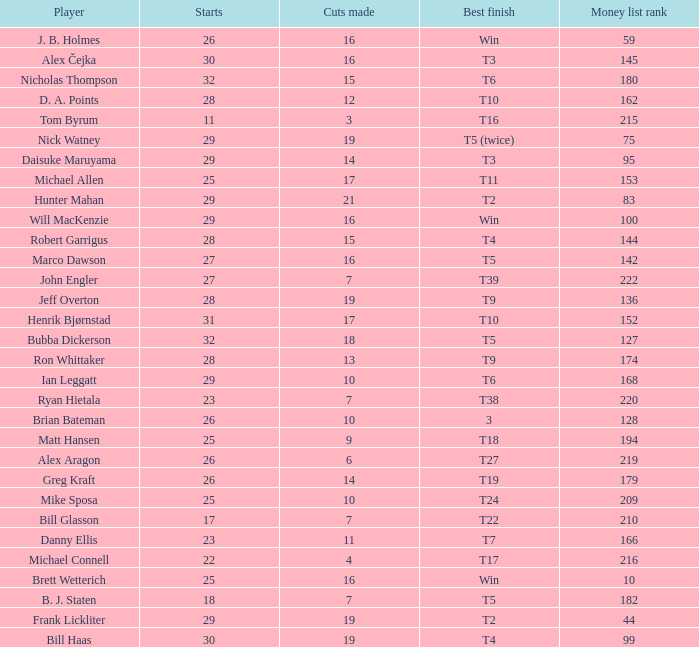What is the maximum money list rank for Matt Hansen? 194.0. 